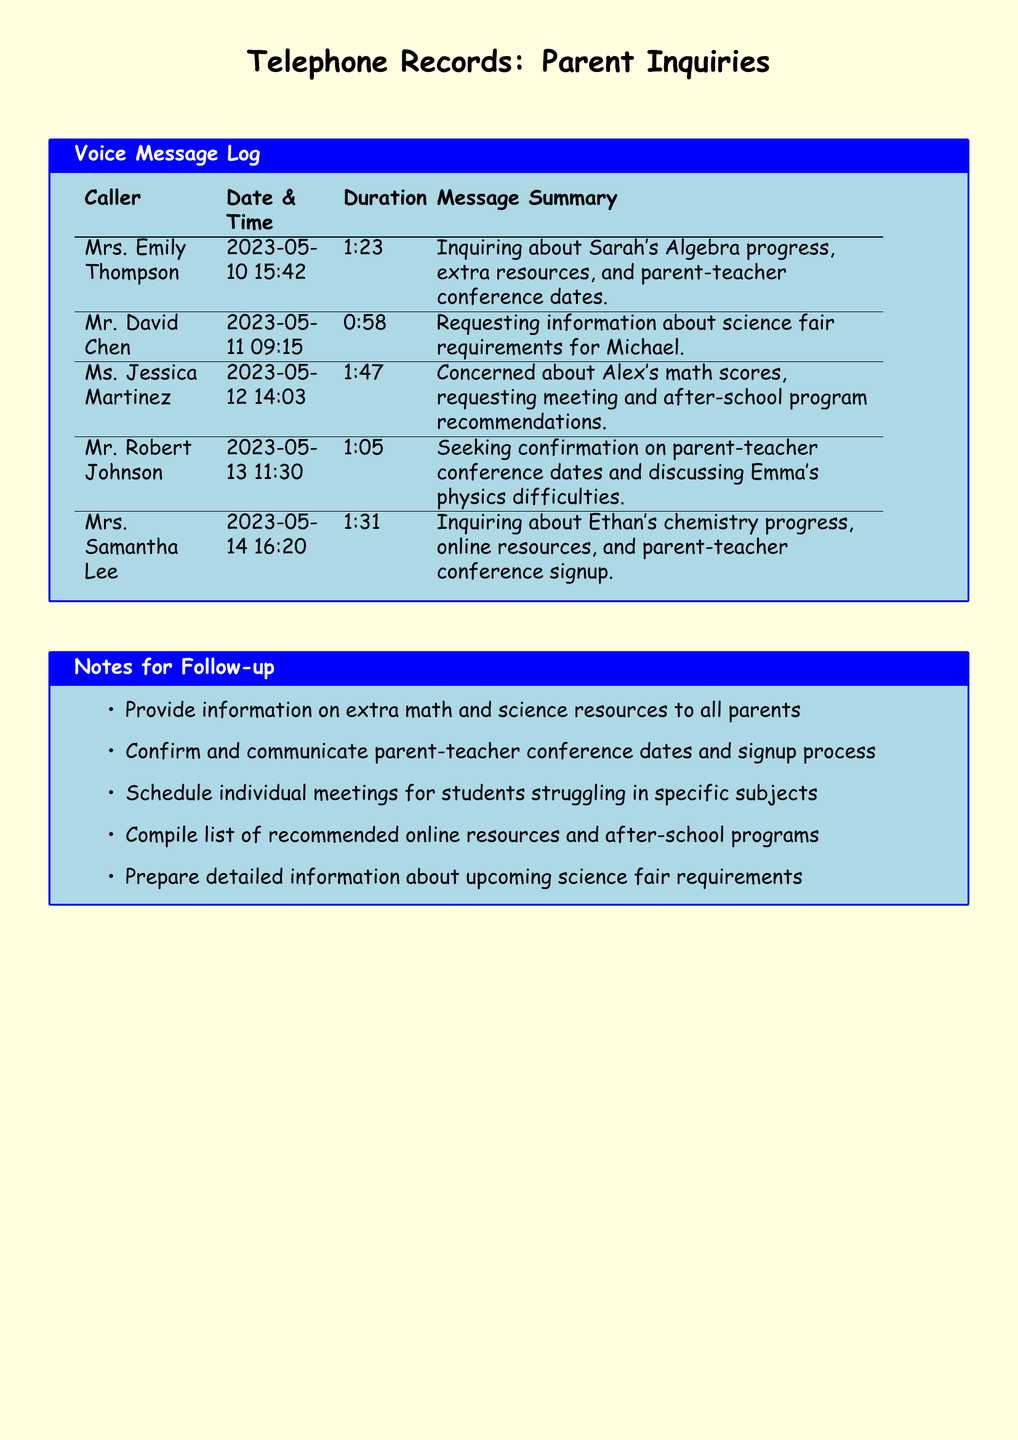What is the total number of voice messages? The document contains a log of five voice messages left by parents.
Answer: 5 Who left a message on May 12? The log indicates that Ms. Jessica Martinez left a message on this date.
Answer: Ms. Jessica Martinez What subject is Sarah struggling with? Mrs. Emily Thompson inquired about Sarah's progress specifically in Algebra.
Answer: Algebra How long was Mr. David Chen's call? The duration of Mr. David Chen's call was mentioned as 0:58.
Answer: 0:58 What was one of the concerns expressed by Ms. Jessica Martinez? Ms. Jessica Martinez was particularly concerned about Alex's math scores.
Answer: Alex's math scores What is one action noted for follow-up regarding parent meetings? The notes indicate to confirm and communicate the parent-teacher conference dates.
Answer: Confirm and communicate parent-teacher conference dates Which parent inquired about chemistry? Mrs. Samantha Lee specifically inquired about Ethan's chemistry progress.
Answer: Mrs. Samantha Lee What date did Mr. Robert Johnson leave his message? The date of Mr. Robert Johnson's message is listed as May 13.
Answer: May 13 